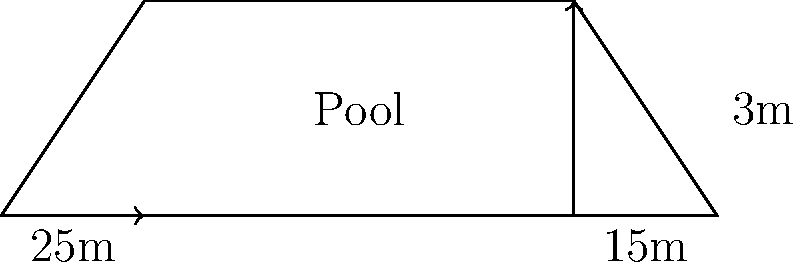A trapezoidal swimming pool has parallel sides measuring 25m and 15m, with a height of 3m between them. Calculate the area of the pool in square meters. To find the area of a trapezoid, we can use the formula:

$$ A = \frac{1}{2}(b_1 + b_2)h $$

Where:
$A$ = area
$b_1$ and $b_2$ = lengths of the parallel sides
$h$ = height (perpendicular distance between the parallel sides)

Given:
$b_1 = 25m$
$b_2 = 15m$
$h = 3m$

Let's substitute these values into the formula:

$$ A = \frac{1}{2}(25m + 15m) \times 3m $$
$$ A = \frac{1}{2}(40m) \times 3m $$
$$ A = 20m \times 3m $$
$$ A = 60m^2 $$

Therefore, the area of the trapezoidal swimming pool is 60 square meters.
Answer: $60m^2$ 